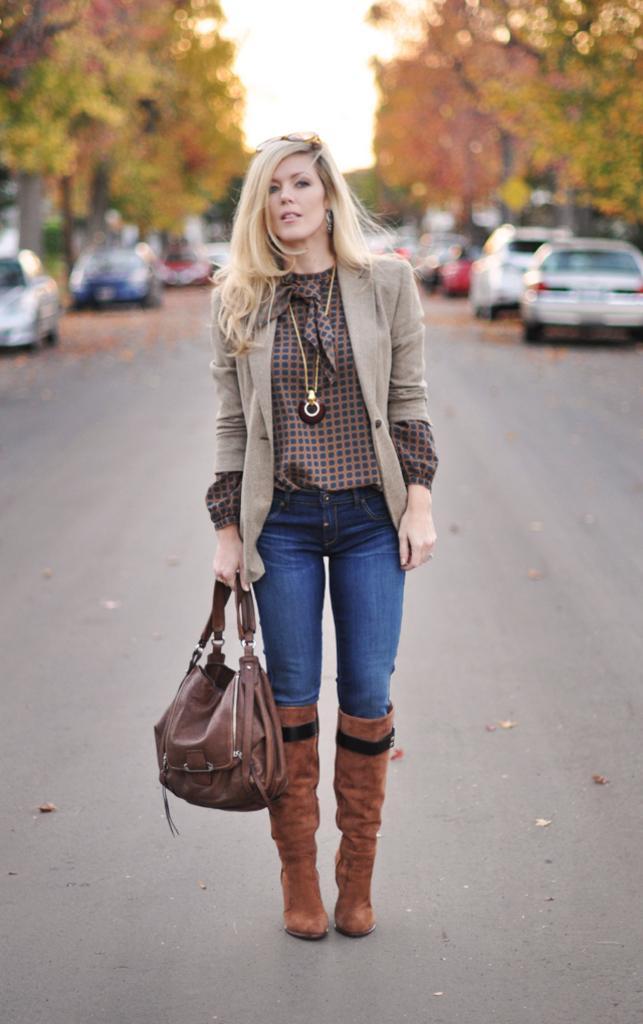Could you give a brief overview of what you see in this image? This woman is standing and holding a handbag. Far there are number of vehicles and trees. This woman wore jacket. 